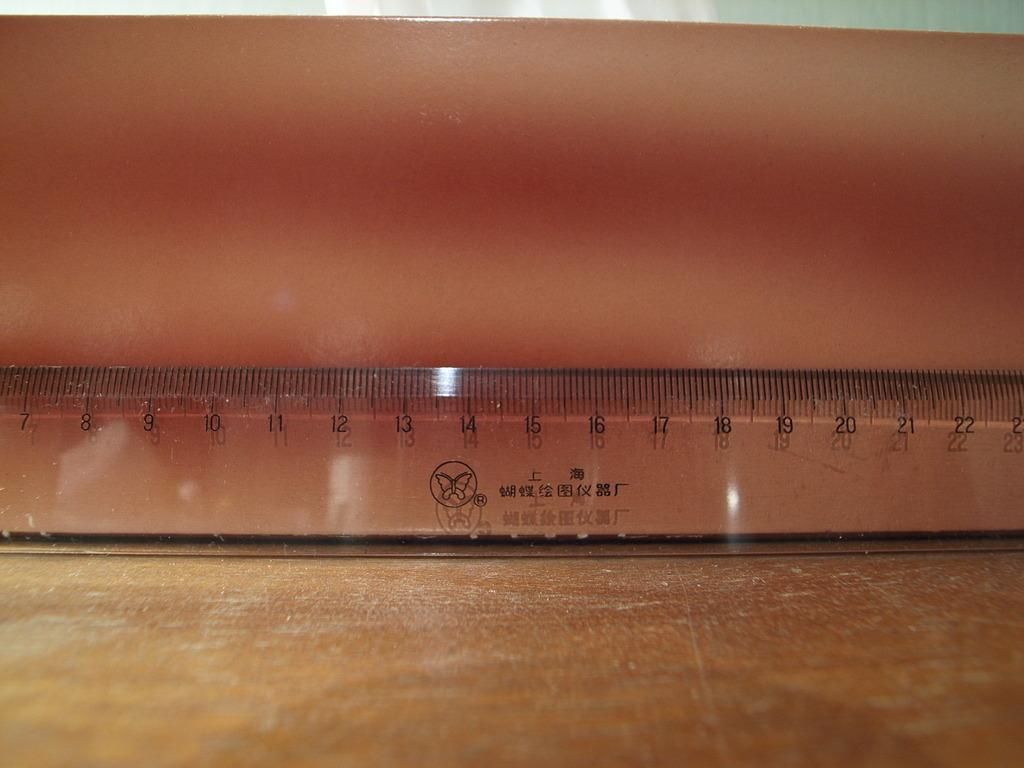<image>
Share a concise interpretation of the image provided. Clear ruler with Chinese characters on it showing numbers from 7 to 22 